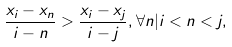Convert formula to latex. <formula><loc_0><loc_0><loc_500><loc_500>\frac { x _ { i } - x _ { n } } { i - n } > \frac { x _ { i } - x _ { j } } { i - j } , \forall { n } | i < n < j ,</formula> 